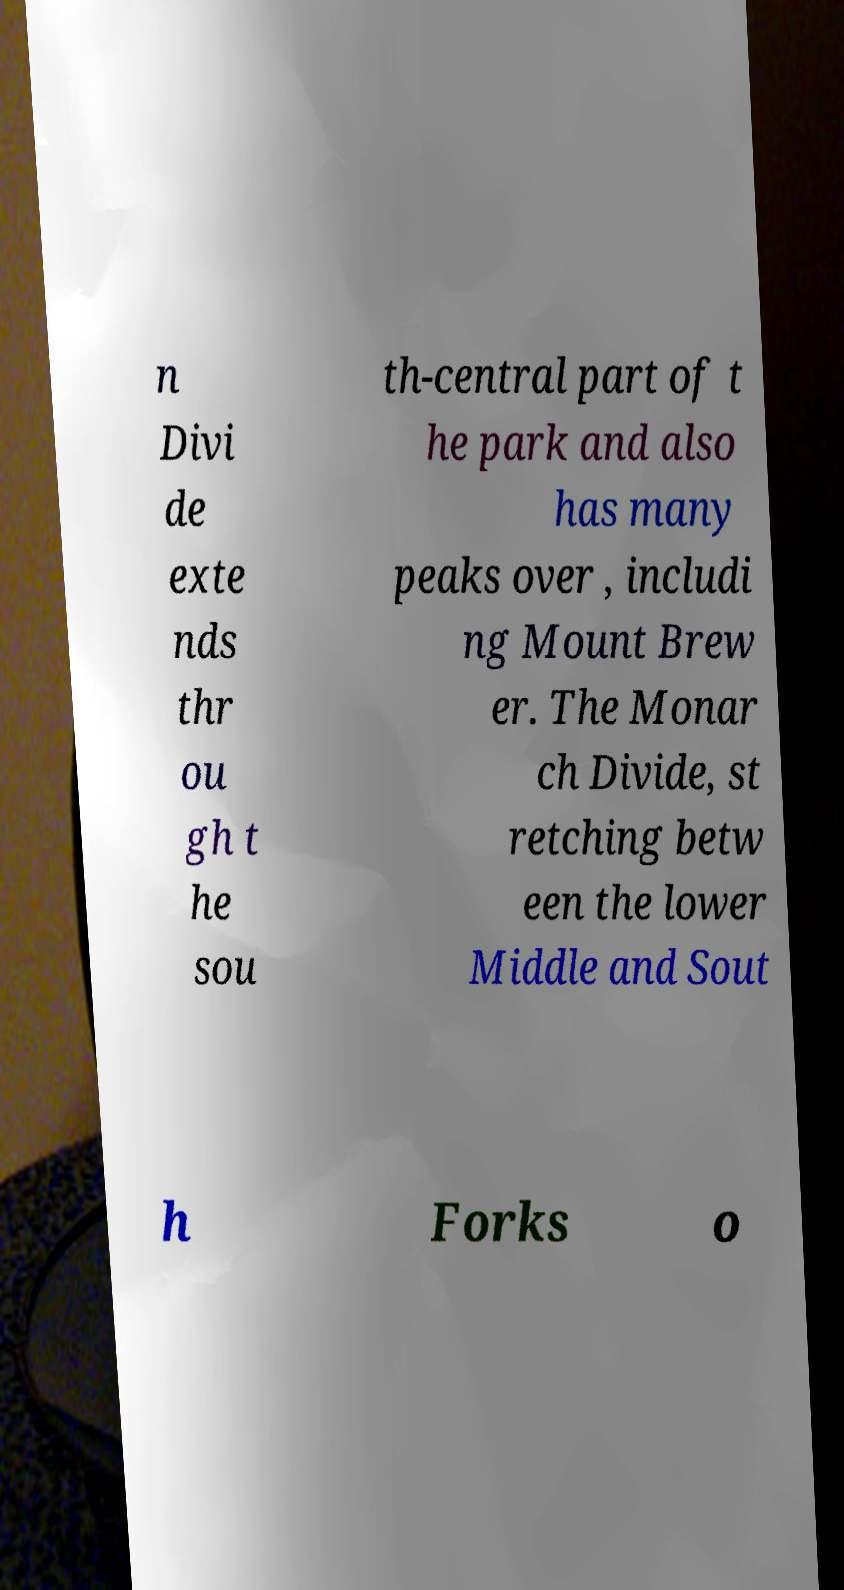Can you accurately transcribe the text from the provided image for me? n Divi de exte nds thr ou gh t he sou th-central part of t he park and also has many peaks over , includi ng Mount Brew er. The Monar ch Divide, st retching betw een the lower Middle and Sout h Forks o 